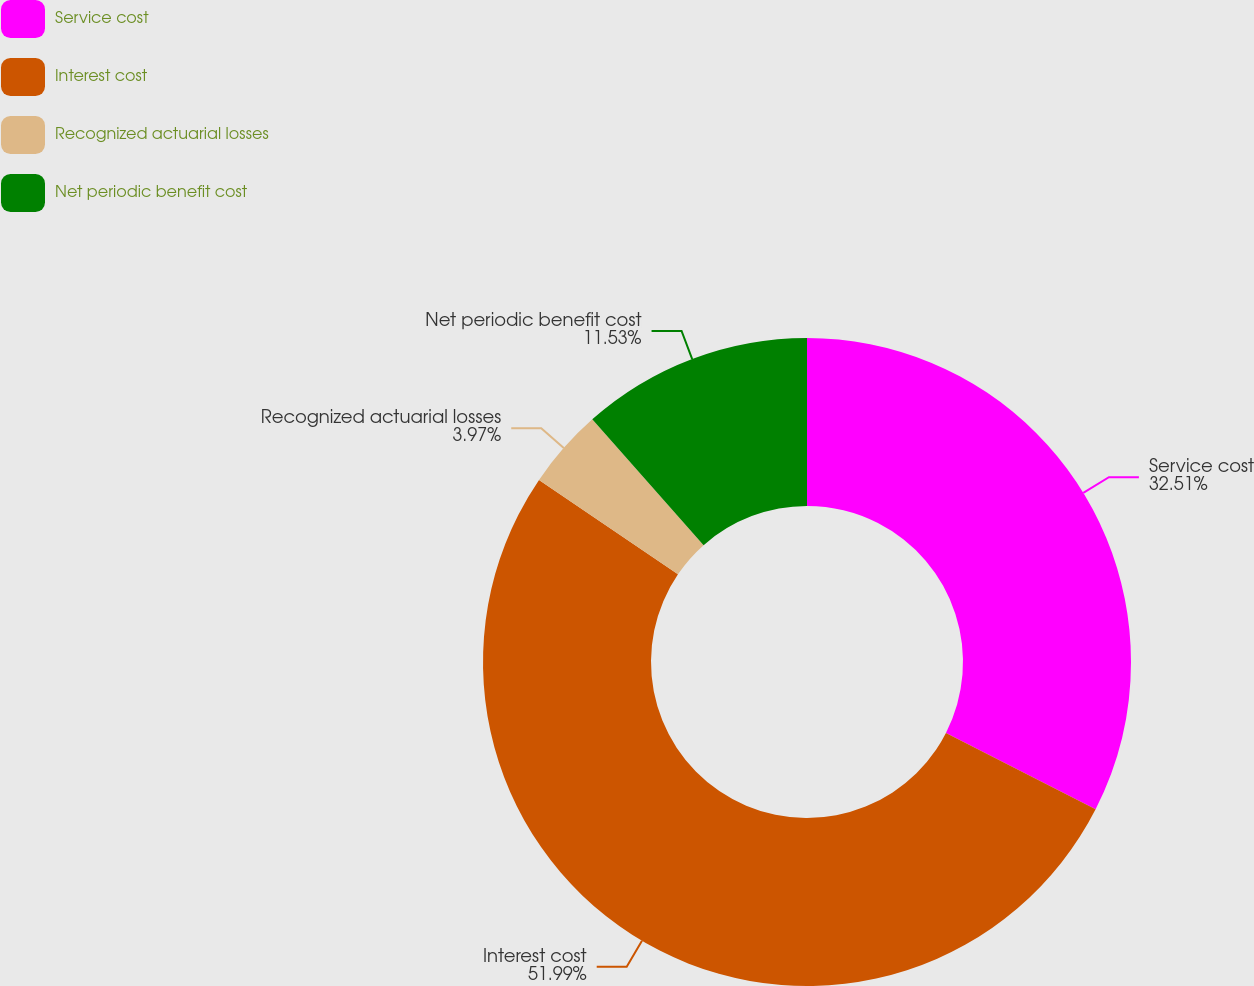Convert chart to OTSL. <chart><loc_0><loc_0><loc_500><loc_500><pie_chart><fcel>Service cost<fcel>Interest cost<fcel>Recognized actuarial losses<fcel>Net periodic benefit cost<nl><fcel>32.51%<fcel>51.99%<fcel>3.97%<fcel>11.53%<nl></chart> 